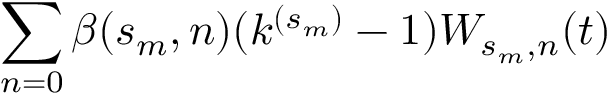<formula> <loc_0><loc_0><loc_500><loc_500>\sum _ { n = 0 } \beta ( s _ { m } , n ) ( k ^ { ( s _ { m } ) } - 1 ) W _ { s _ { m } , n } ( t )</formula> 